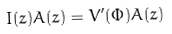Convert formula to latex. <formula><loc_0><loc_0><loc_500><loc_500>I ( z ) A ( z ) = V ^ { \prime } ( \Phi ) A ( z )</formula> 